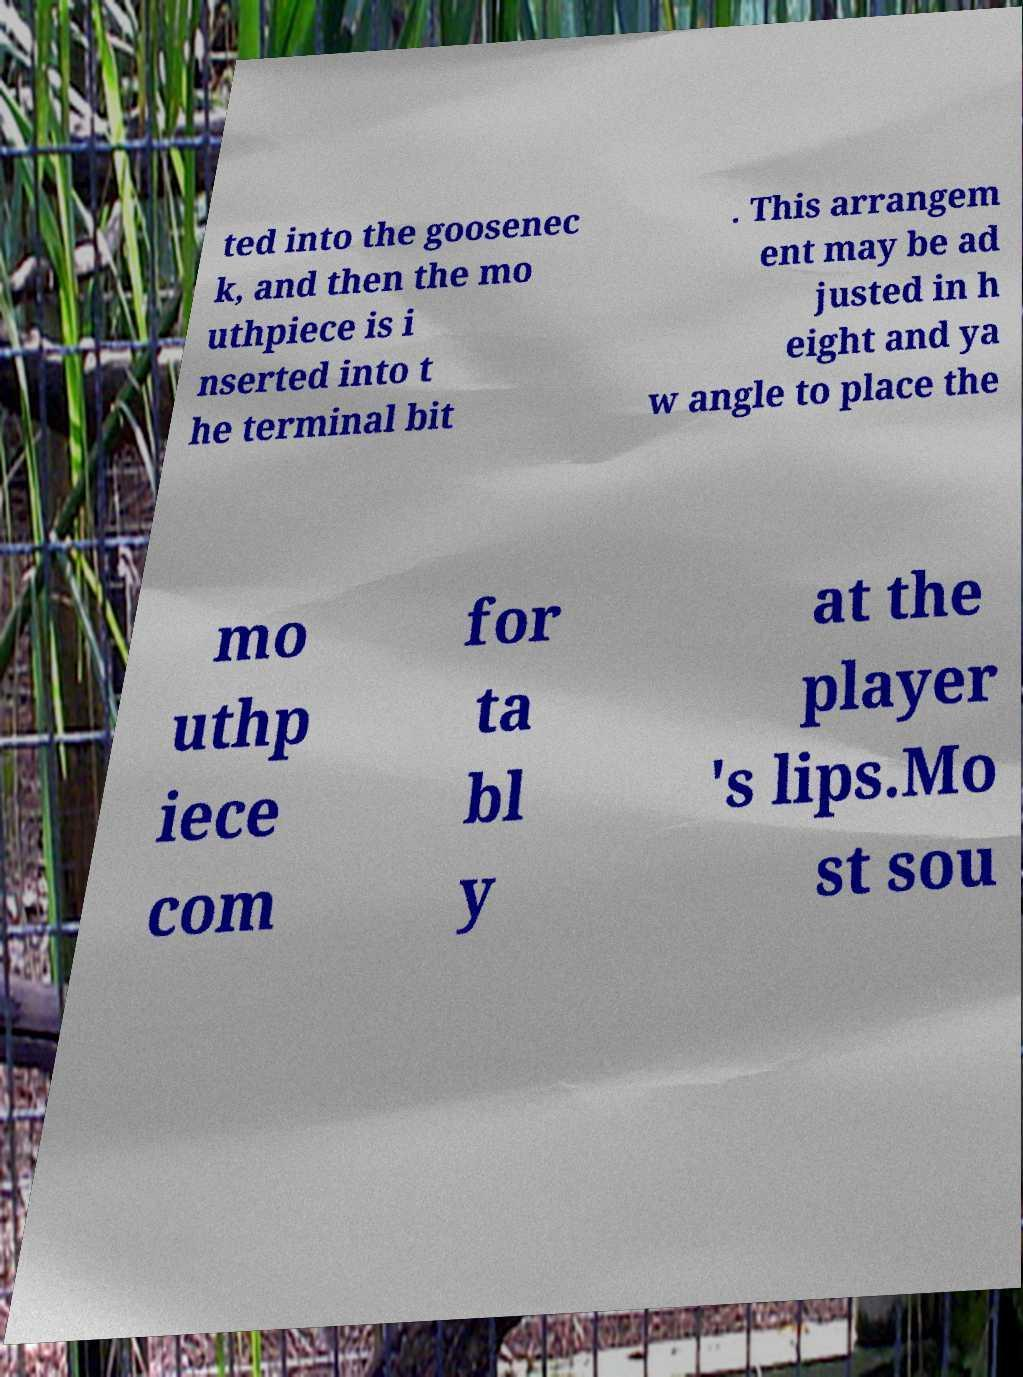For documentation purposes, I need the text within this image transcribed. Could you provide that? ted into the goosenec k, and then the mo uthpiece is i nserted into t he terminal bit . This arrangem ent may be ad justed in h eight and ya w angle to place the mo uthp iece com for ta bl y at the player 's lips.Mo st sou 